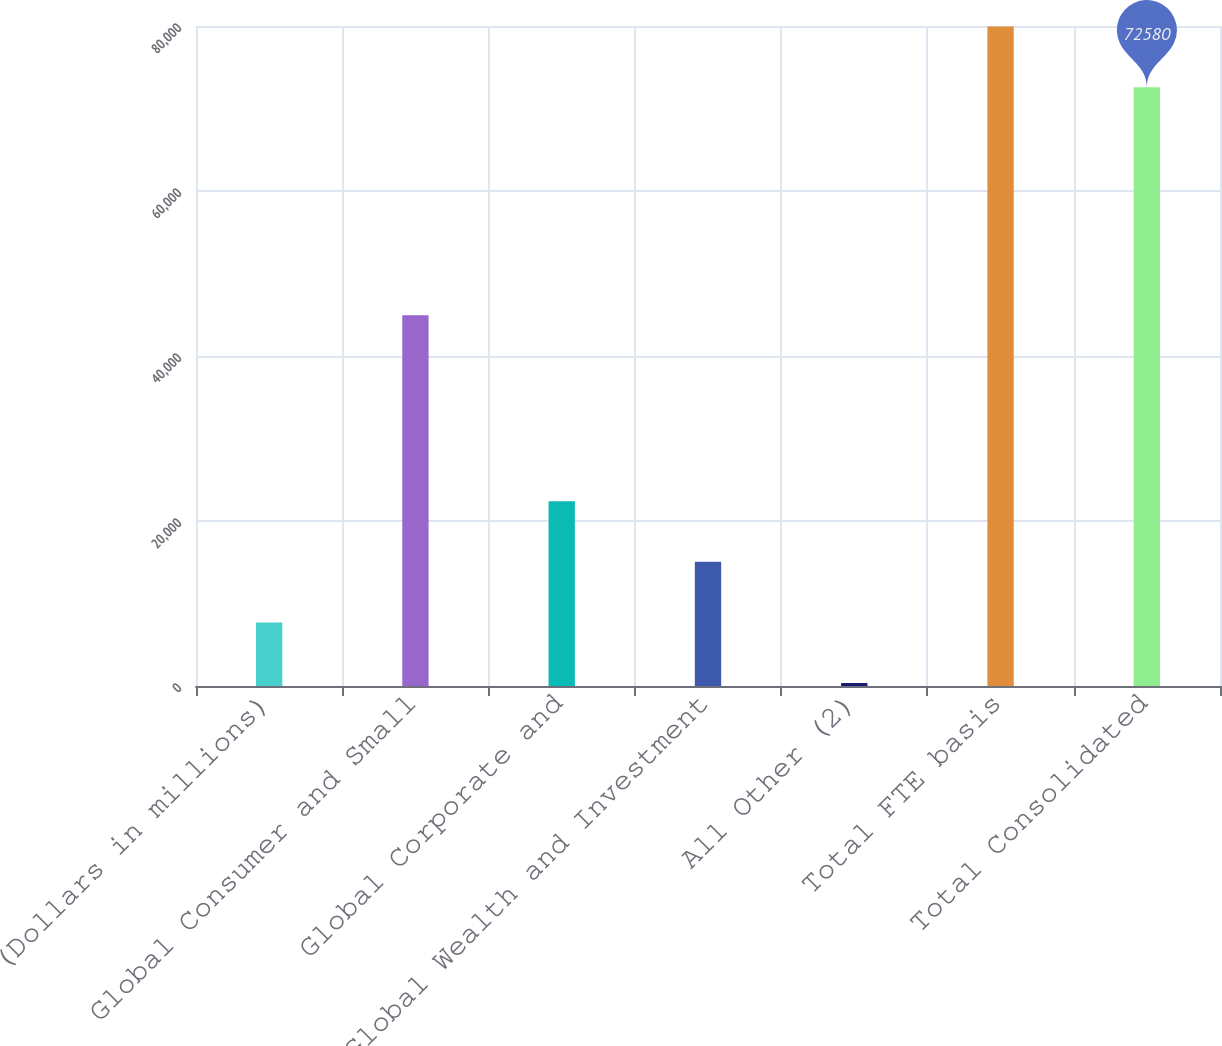Convert chart to OTSL. <chart><loc_0><loc_0><loc_500><loc_500><bar_chart><fcel>(Dollars in millions)<fcel>Global Consumer and Small<fcel>Global Corporate and<fcel>Global Wealth and Investment<fcel>All Other (2)<fcel>Total FTE basis<fcel>Total Consolidated<nl><fcel>7704.4<fcel>44926<fcel>22393.2<fcel>15048.8<fcel>360<fcel>79924.4<fcel>72580<nl></chart> 